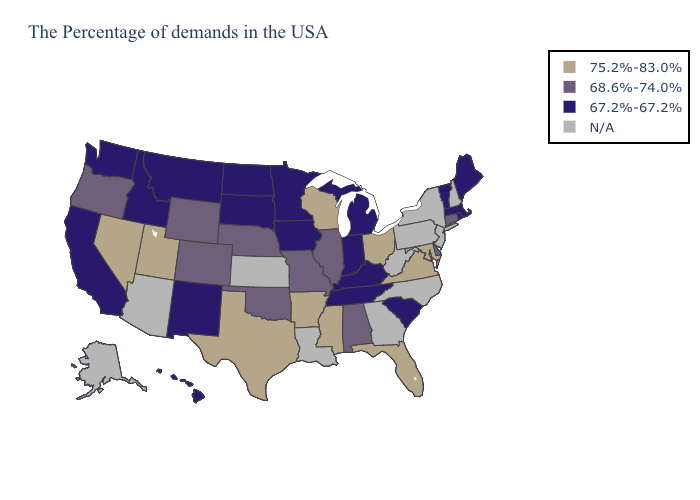What is the highest value in the Northeast ?
Concise answer only. 68.6%-74.0%. Which states have the lowest value in the MidWest?
Quick response, please. Michigan, Indiana, Minnesota, Iowa, South Dakota, North Dakota. Which states have the lowest value in the USA?
Short answer required. Maine, Massachusetts, Rhode Island, Vermont, South Carolina, Michigan, Kentucky, Indiana, Tennessee, Minnesota, Iowa, South Dakota, North Dakota, New Mexico, Montana, Idaho, California, Washington, Hawaii. What is the highest value in states that border Pennsylvania?
Answer briefly. 75.2%-83.0%. Among the states that border Rhode Island , does Massachusetts have the highest value?
Keep it brief. No. Name the states that have a value in the range 68.6%-74.0%?
Quick response, please. Connecticut, Delaware, Alabama, Illinois, Missouri, Nebraska, Oklahoma, Wyoming, Colorado, Oregon. What is the highest value in the USA?
Be succinct. 75.2%-83.0%. What is the lowest value in the USA?
Short answer required. 67.2%-67.2%. Name the states that have a value in the range 68.6%-74.0%?
Write a very short answer. Connecticut, Delaware, Alabama, Illinois, Missouri, Nebraska, Oklahoma, Wyoming, Colorado, Oregon. Name the states that have a value in the range 68.6%-74.0%?
Concise answer only. Connecticut, Delaware, Alabama, Illinois, Missouri, Nebraska, Oklahoma, Wyoming, Colorado, Oregon. What is the lowest value in the USA?
Concise answer only. 67.2%-67.2%. What is the value of Texas?
Give a very brief answer. 75.2%-83.0%. Does the first symbol in the legend represent the smallest category?
Give a very brief answer. No. What is the value of Vermont?
Give a very brief answer. 67.2%-67.2%. 